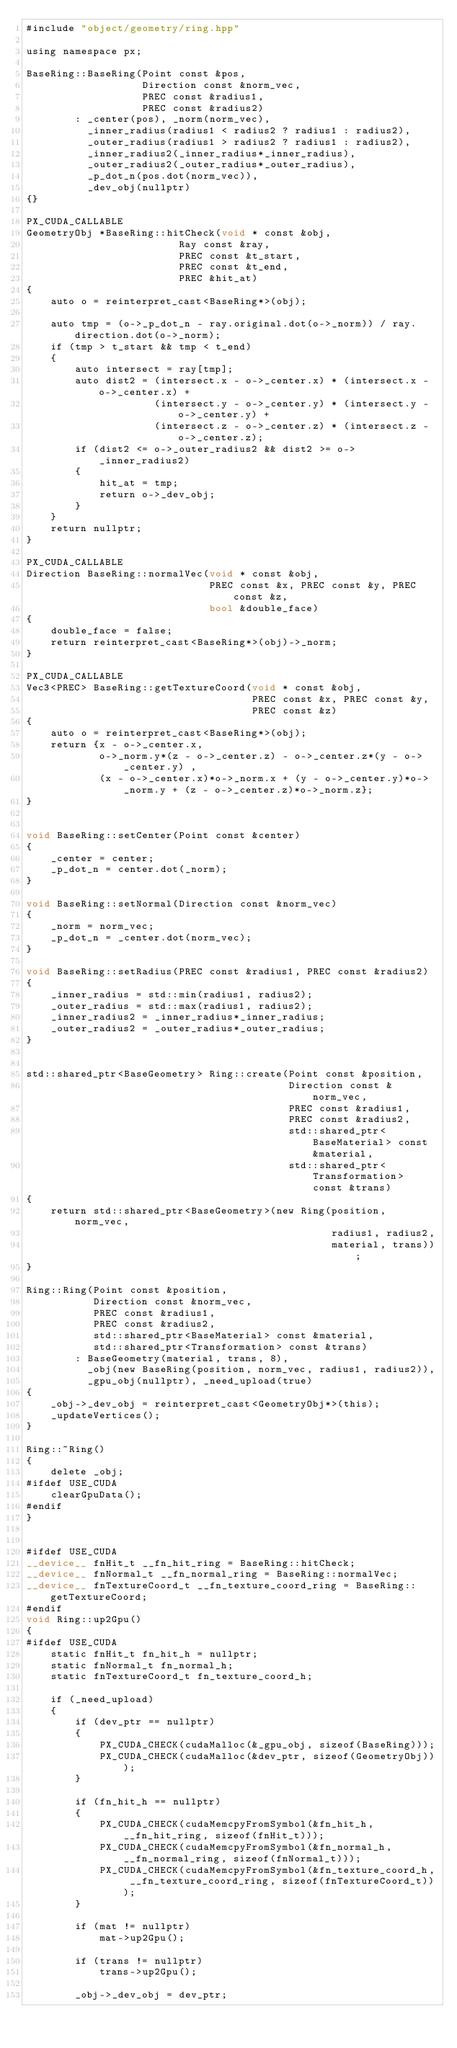Convert code to text. <code><loc_0><loc_0><loc_500><loc_500><_Cuda_>#include "object/geometry/ring.hpp"

using namespace px;

BaseRing::BaseRing(Point const &pos,
                   Direction const &norm_vec,
                   PREC const &radius1,
                   PREC const &radius2)
        : _center(pos), _norm(norm_vec),
          _inner_radius(radius1 < radius2 ? radius1 : radius2),
          _outer_radius(radius1 > radius2 ? radius1 : radius2),
          _inner_radius2(_inner_radius*_inner_radius),
          _outer_radius2(_outer_radius*_outer_radius),
          _p_dot_n(pos.dot(norm_vec)),
          _dev_obj(nullptr)
{}

PX_CUDA_CALLABLE
GeometryObj *BaseRing::hitCheck(void * const &obj,
                         Ray const &ray,
                         PREC const &t_start,
                         PREC const &t_end,
                         PREC &hit_at)
{
    auto o = reinterpret_cast<BaseRing*>(obj);

    auto tmp = (o->_p_dot_n - ray.original.dot(o->_norm)) / ray.direction.dot(o->_norm);
    if (tmp > t_start && tmp < t_end)
    {
        auto intersect = ray[tmp];
        auto dist2 = (intersect.x - o->_center.x) * (intersect.x - o->_center.x) +
                     (intersect.y - o->_center.y) * (intersect.y - o->_center.y) +
                     (intersect.z - o->_center.z) * (intersect.z - o->_center.z);
        if (dist2 <= o->_outer_radius2 && dist2 >= o->_inner_radius2)
        {
            hit_at = tmp;
            return o->_dev_obj;
        }
    }
    return nullptr;
}

PX_CUDA_CALLABLE
Direction BaseRing::normalVec(void * const &obj,
                              PREC const &x, PREC const &y, PREC const &z,
                              bool &double_face)
{
    double_face = false;
    return reinterpret_cast<BaseRing*>(obj)->_norm;
}

PX_CUDA_CALLABLE
Vec3<PREC> BaseRing::getTextureCoord(void * const &obj,
                                     PREC const &x, PREC const &y,
                                     PREC const &z)
{
    auto o = reinterpret_cast<BaseRing*>(obj);
    return {x - o->_center.x,
            o->_norm.y*(z - o->_center.z) - o->_center.z*(y - o->_center.y) ,
            (x - o->_center.x)*o->_norm.x + (y - o->_center.y)*o->_norm.y + (z - o->_center.z)*o->_norm.z};
}


void BaseRing::setCenter(Point const &center)
{
    _center = center;
    _p_dot_n = center.dot(_norm);
}

void BaseRing::setNormal(Direction const &norm_vec)
{
    _norm = norm_vec;
    _p_dot_n = _center.dot(norm_vec);
}

void BaseRing::setRadius(PREC const &radius1, PREC const &radius2)
{
    _inner_radius = std::min(radius1, radius2);
    _outer_radius = std::max(radius1, radius2);
    _inner_radius2 = _inner_radius*_inner_radius;
    _outer_radius2 = _outer_radius*_outer_radius;
}


std::shared_ptr<BaseGeometry> Ring::create(Point const &position,
                                           Direction const &norm_vec,
                                           PREC const &radius1,
                                           PREC const &radius2,
                                           std::shared_ptr<BaseMaterial> const &material,
                                           std::shared_ptr<Transformation> const &trans)
{
    return std::shared_ptr<BaseGeometry>(new Ring(position, norm_vec,
                                                  radius1, radius2,
                                                  material, trans));
}

Ring::Ring(Point const &position,
           Direction const &norm_vec,
           PREC const &radius1,
           PREC const &radius2,
           std::shared_ptr<BaseMaterial> const &material,
           std::shared_ptr<Transformation> const &trans)
        : BaseGeometry(material, trans, 8),
          _obj(new BaseRing(position, norm_vec, radius1, radius2)),
          _gpu_obj(nullptr), _need_upload(true)
{
    _obj->_dev_obj = reinterpret_cast<GeometryObj*>(this);
    _updateVertices();
}

Ring::~Ring()
{
    delete _obj;
#ifdef USE_CUDA
    clearGpuData();
#endif
}


#ifdef USE_CUDA
__device__ fnHit_t __fn_hit_ring = BaseRing::hitCheck;
__device__ fnNormal_t __fn_normal_ring = BaseRing::normalVec;
__device__ fnTextureCoord_t __fn_texture_coord_ring = BaseRing::getTextureCoord;
#endif
void Ring::up2Gpu()
{
#ifdef USE_CUDA
    static fnHit_t fn_hit_h = nullptr;
    static fnNormal_t fn_normal_h;
    static fnTextureCoord_t fn_texture_coord_h;

    if (_need_upload)
    {
        if (dev_ptr == nullptr)
        {
            PX_CUDA_CHECK(cudaMalloc(&_gpu_obj, sizeof(BaseRing)));
            PX_CUDA_CHECK(cudaMalloc(&dev_ptr, sizeof(GeometryObj)));
        }

        if (fn_hit_h == nullptr)
        {
            PX_CUDA_CHECK(cudaMemcpyFromSymbol(&fn_hit_h, __fn_hit_ring, sizeof(fnHit_t)));
            PX_CUDA_CHECK(cudaMemcpyFromSymbol(&fn_normal_h, __fn_normal_ring, sizeof(fnNormal_t)));
            PX_CUDA_CHECK(cudaMemcpyFromSymbol(&fn_texture_coord_h, __fn_texture_coord_ring, sizeof(fnTextureCoord_t)));
        }

        if (mat != nullptr)
            mat->up2Gpu();

        if (trans != nullptr)
            trans->up2Gpu();

        _obj->_dev_obj = dev_ptr;</code> 